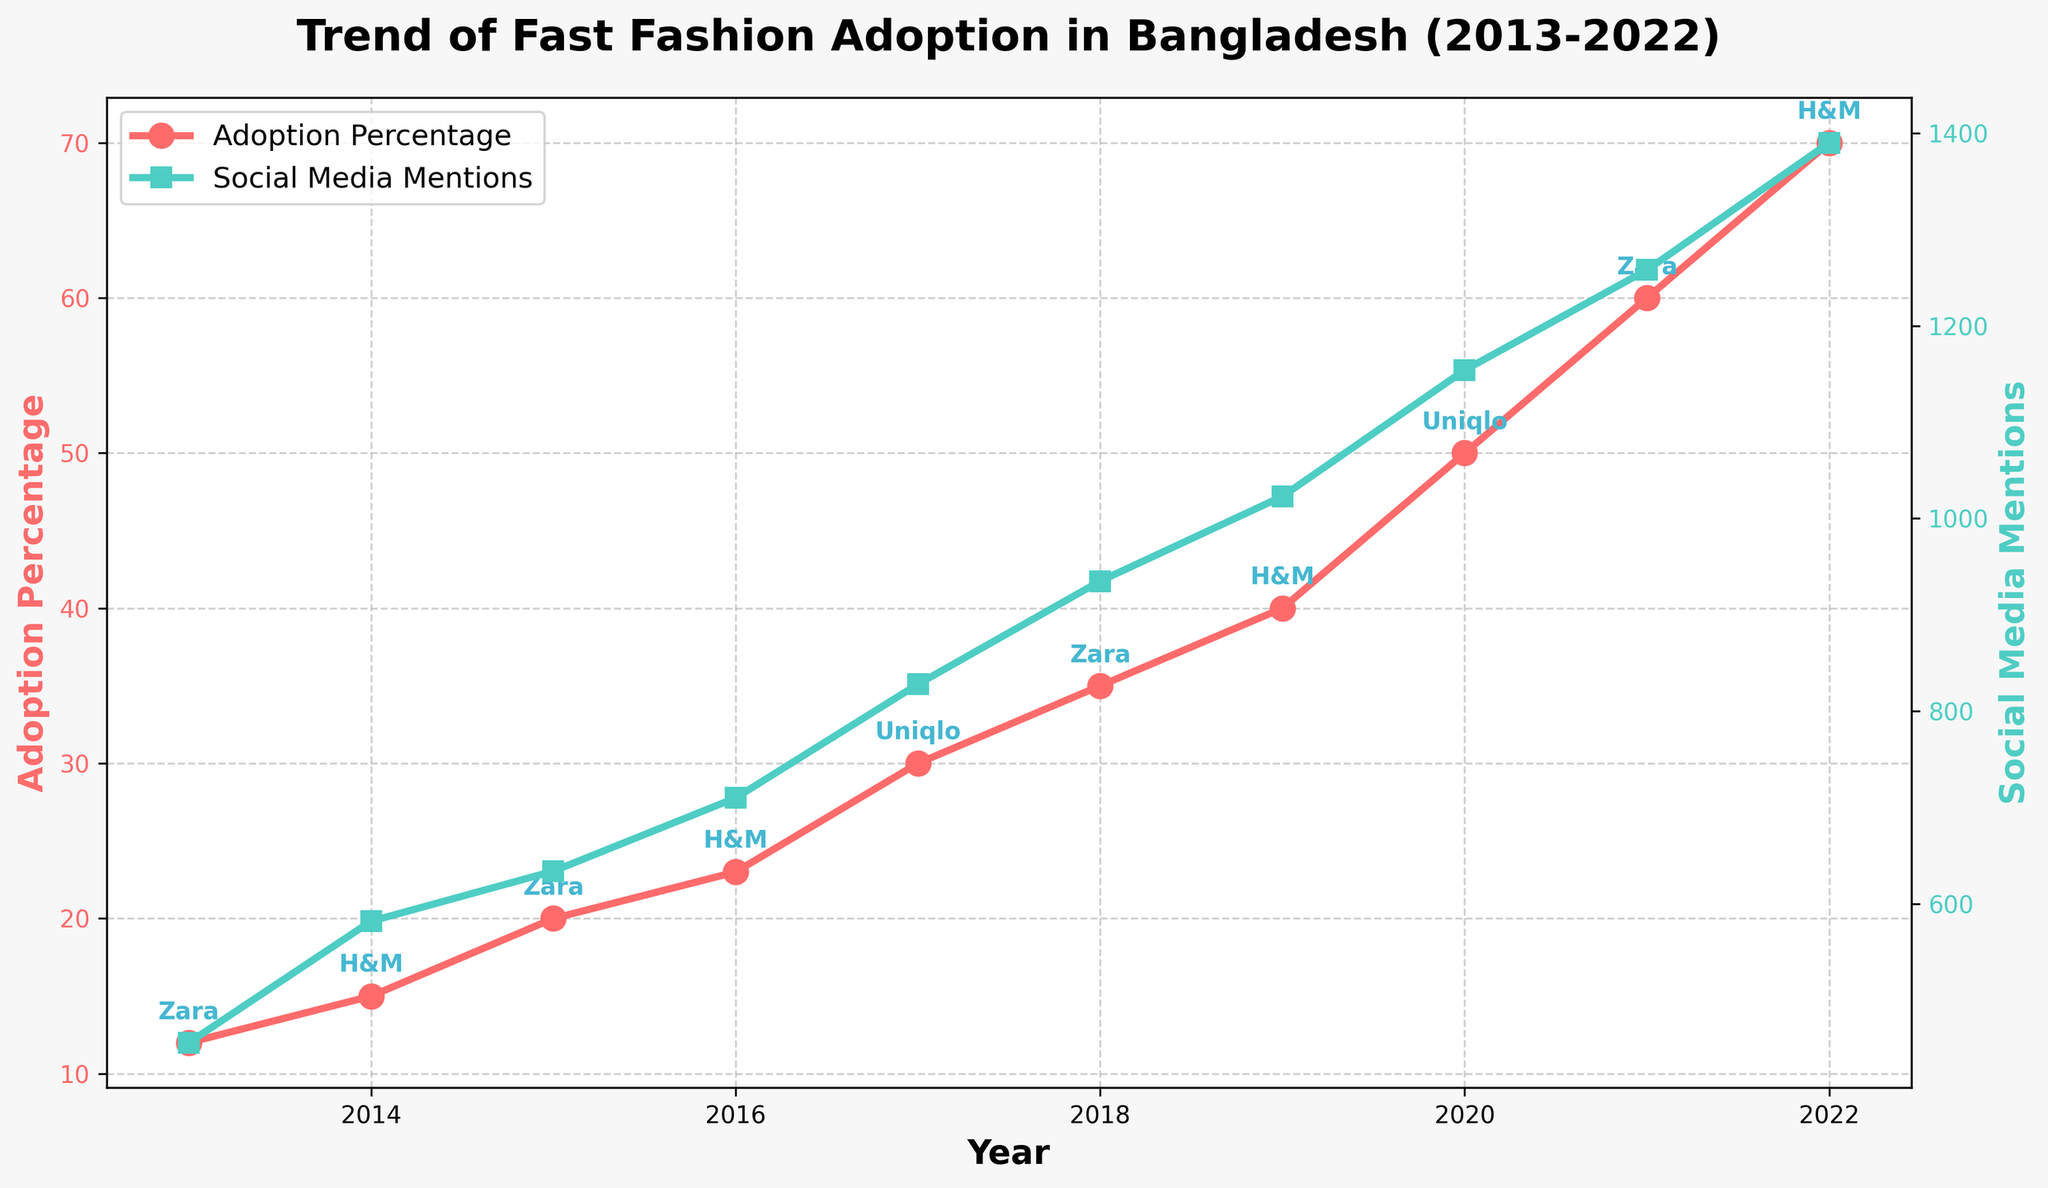What's the title of the plot? The title is typically found at the top of the plot. In this case, it reads: "Trend of Fast Fashion Adoption in Bangladesh (2013-2022)."
Answer: Trend of Fast Fashion Adoption in Bangladesh (2013-2022) How does the adoption percentage trend change over the decade? From the figure, one can observe the line representing the percentage adoption. It starts at 12% in 2013 and increases each year, reaching 70% in 2022.
Answer: It steadily increases Which year had the highest social media mentions? By examining the social media mentions line, the highest value is at the end of the plot. The highest social media mentions occur in 2022 with a value of 1390.
Answer: 2022 Which brand was most popular in 2017? The brand names are annotated near the data points. In 2017, the brand marked on the plot is "Uniqlo".
Answer: Uniqlo Compare the social media mentions in 2020 with those in 2016. Which year had more mentions? According to the social media mentions line, the value for 2020 is higher than 2016. The exact values are 1154 for 2020 and 710 for 2016.
Answer: 2020 What is the difference in adoption percentage between 2020 and 2013? The adoption percentage in 2020 is 50%, and in 2013 it is 12%. Subtracting these gives 50% - 12% = 38%.
Answer: 38% What is the average social media mentions over the decade? Sum up social media mentions from 2013 to 2022 and divide by the number of years. (456 + 582 + 634 + 710 + 828 + 935 + 1023 + 1154 + 1258 + 1390) / 10 = 8970 / 10 = 897.
Answer: 897 In which year did Zara become the most popular brand again after 2015? Checking the annotations, Zara reappears as the most popular brand in 2018 after its previous mark in 2015.
Answer: 2018 Which year showed the highest increase in adoption percentage compared to the previous year? Calculate the year-by-year difference: 2014-2013 (3%), 2015-2014 (5%), 2016-2015 (3%), 2017-2016 (7%), 2018-2017 (5%), 2019-2018 (5%), 2020-2019 (10%), 2021-2020 (10%), 2022-2021 (10%). The highest increase is 10% in 2020, 2021, and 2022.
Answer: 2020, 2021, and 2022 